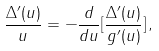<formula> <loc_0><loc_0><loc_500><loc_500>\frac { \Delta ^ { \prime } ( u ) } { u } = - \frac { d } { d u } [ \frac { \Delta ^ { \prime } ( u ) } { g ^ { \prime } ( u ) } ] \, ,</formula> 